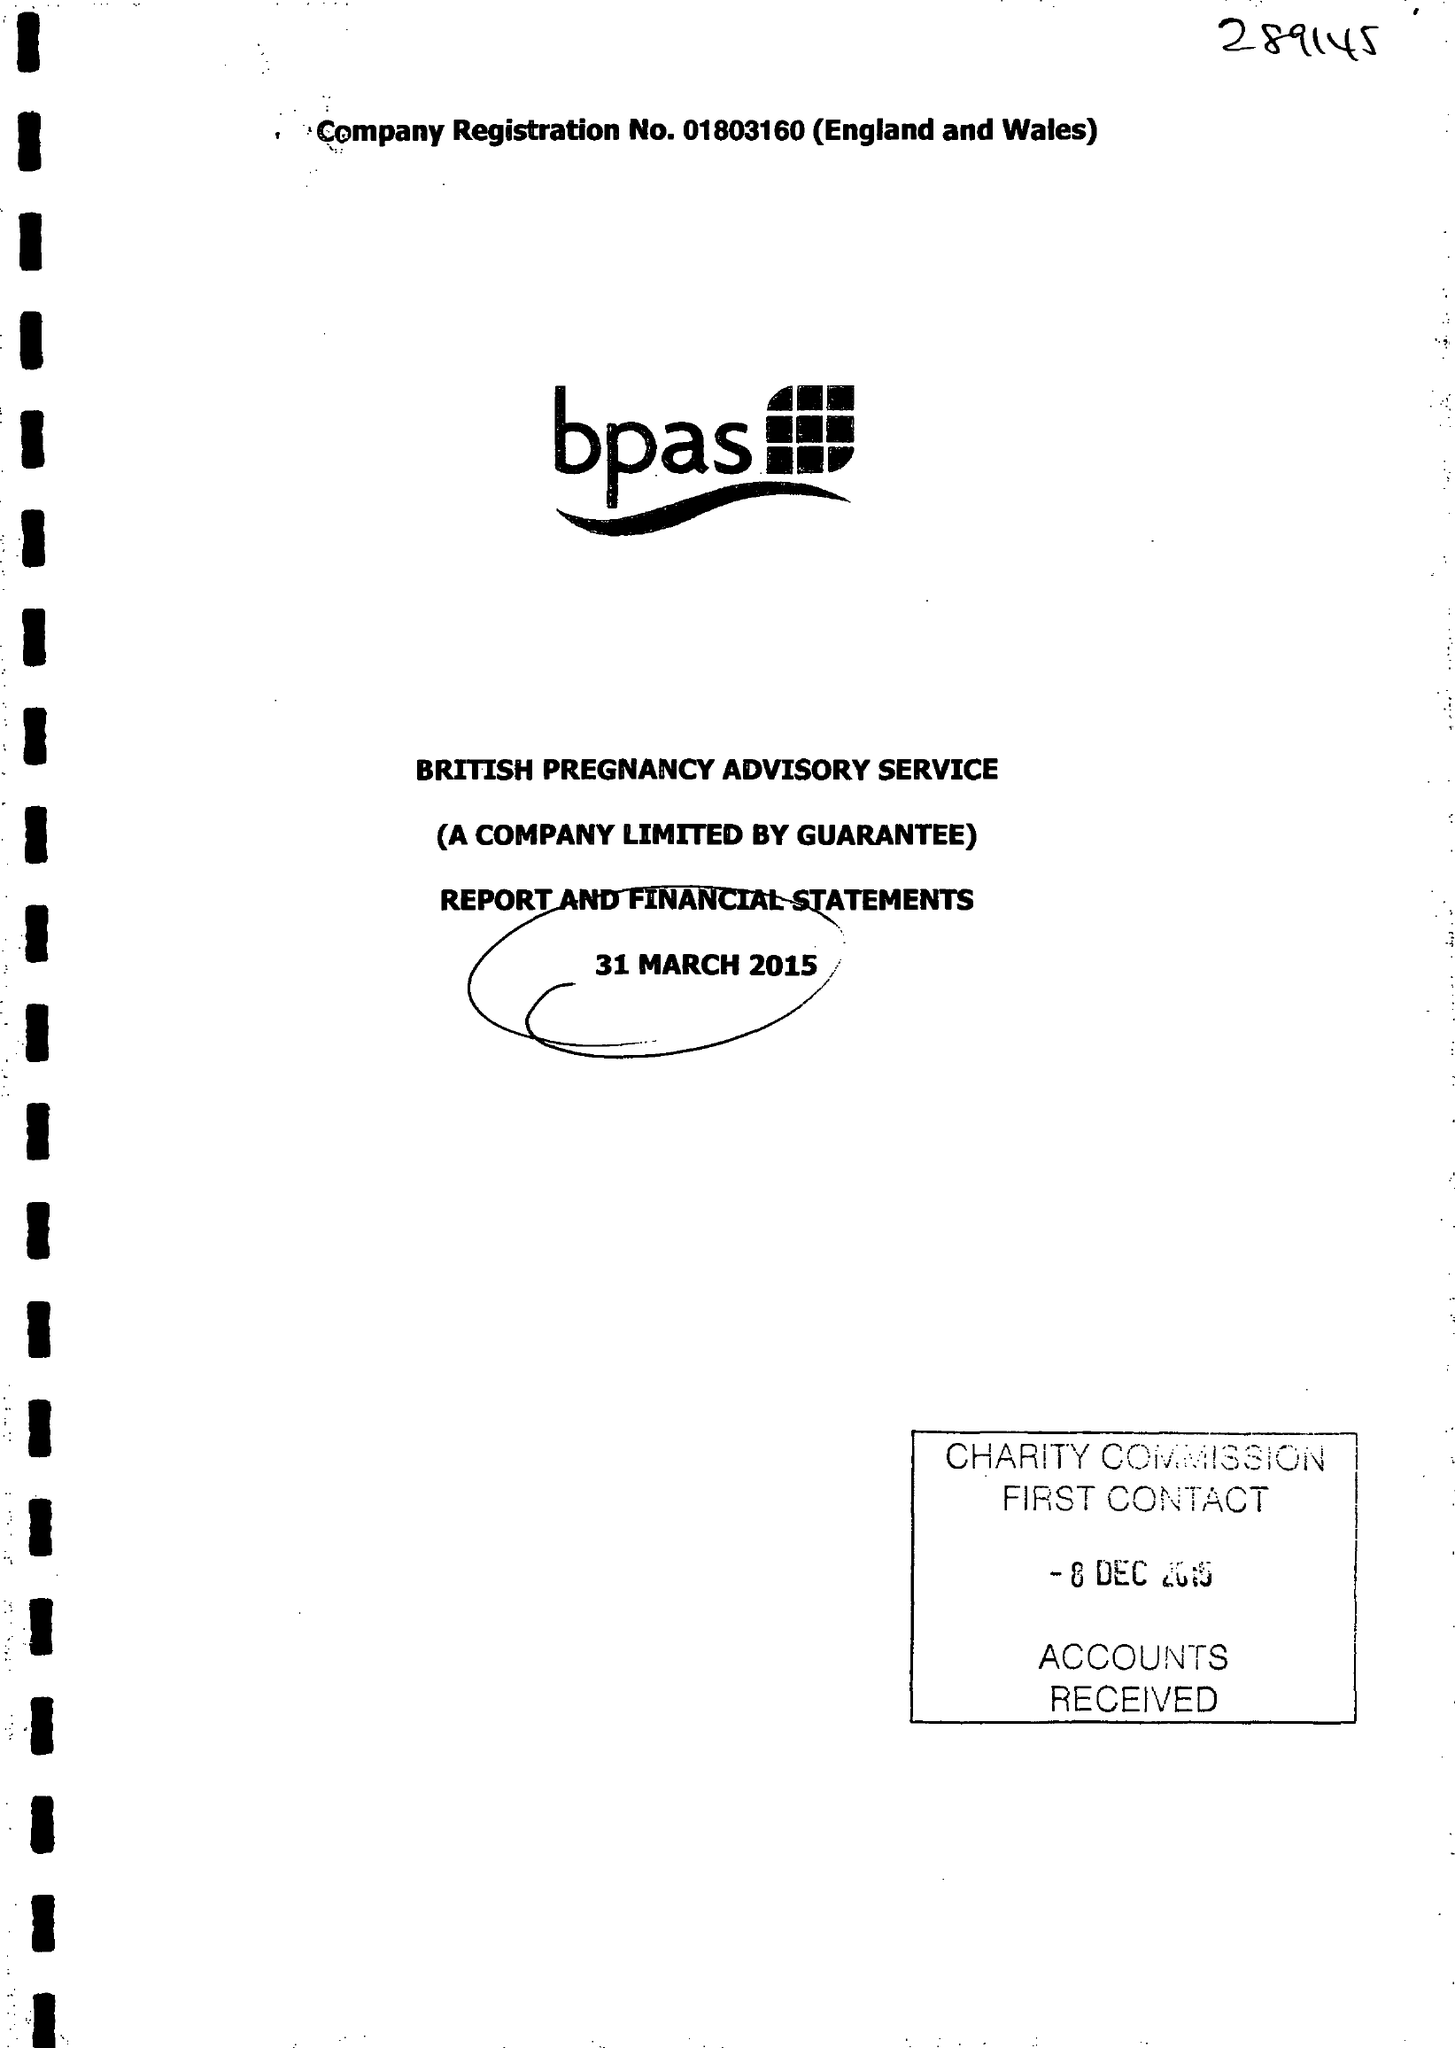What is the value for the address__postcode?
Answer the question using a single word or phrase. CV37 9BF 